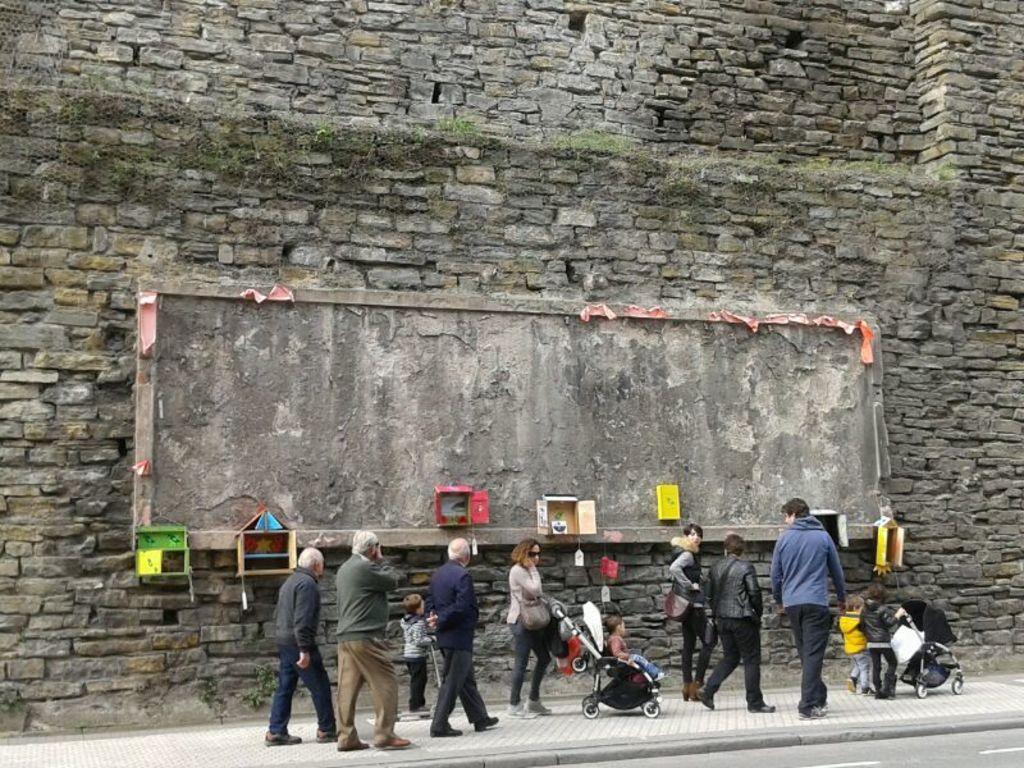Please provide a concise description of this image. In this image we can see some group of persons walking through the sidewalk and at the background of the image we can see stone wall. 